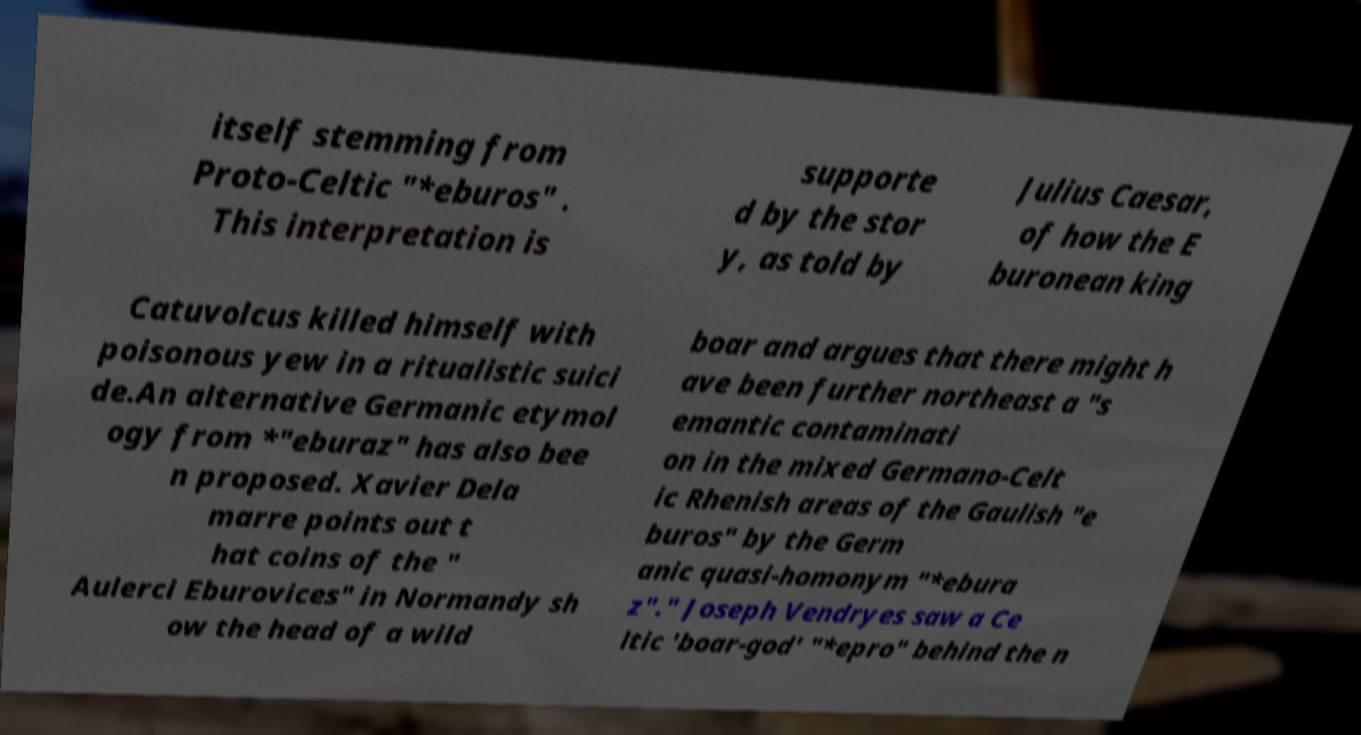Can you accurately transcribe the text from the provided image for me? itself stemming from Proto-Celtic "*eburos" . This interpretation is supporte d by the stor y, as told by Julius Caesar, of how the E buronean king Catuvolcus killed himself with poisonous yew in a ritualistic suici de.An alternative Germanic etymol ogy from *"eburaz" has also bee n proposed. Xavier Dela marre points out t hat coins of the " Aulerci Eburovices" in Normandy sh ow the head of a wild boar and argues that there might h ave been further northeast a "s emantic contaminati on in the mixed Germano-Celt ic Rhenish areas of the Gaulish "e buros" by the Germ anic quasi-homonym "*ebura z"." Joseph Vendryes saw a Ce ltic 'boar-god' "*epro" behind the n 